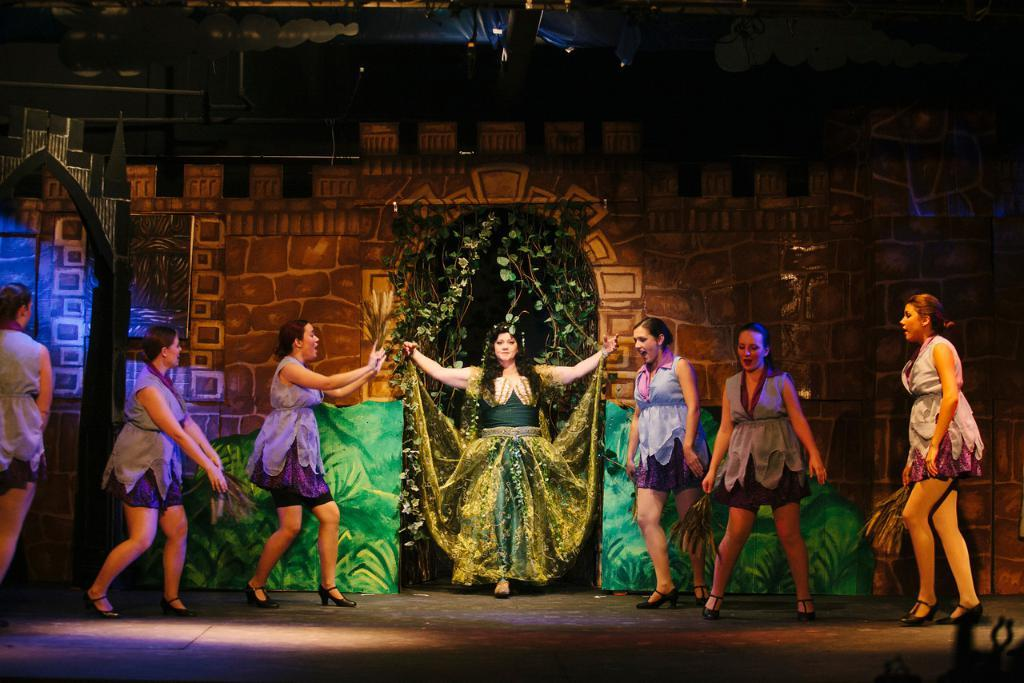What is happening in the foreground of the image? There are girls on the stage in the foreground of the image. What are the girls doing on the stage? The girls appear to be dancing. What can be seen in the background of the image? There is a stage wall visible in the background, and climbers are present in the background. How many men are performing alongside the girls on the stage? There is no mention of men in the image; only girls are visible on the stage. What type of frogs can be seen hopping around the climbers in the background? There are no frogs present in the image; only climbers are visible in the background. 